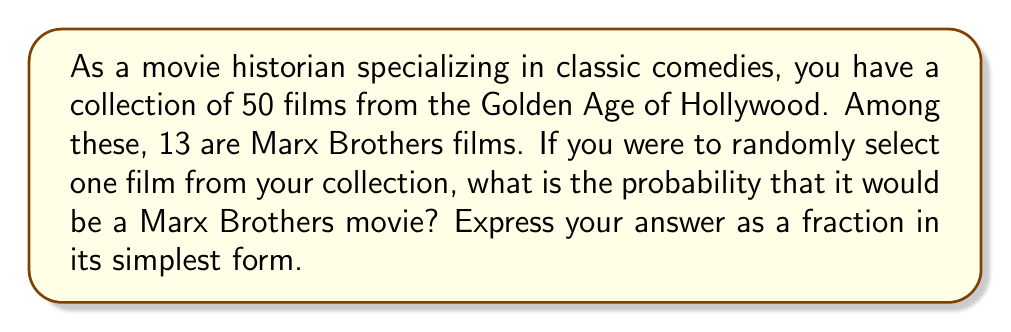Can you answer this question? To solve this problem, we need to use the basic principle of probability:

$$ P(\text{event}) = \frac{\text{number of favorable outcomes}}{\text{total number of possible outcomes}} $$

In this case:
- The total number of possible outcomes is the total number of films in the collection: 50
- The number of favorable outcomes is the number of Marx Brothers films: 13

Therefore, the probability of randomly selecting a Marx Brothers film is:

$$ P(\text{Marx Brothers film}) = \frac{13}{50} $$

This fraction is already in its simplest form, as 13 and 50 have no common factors other than 1.
Answer: $\frac{13}{50}$ 